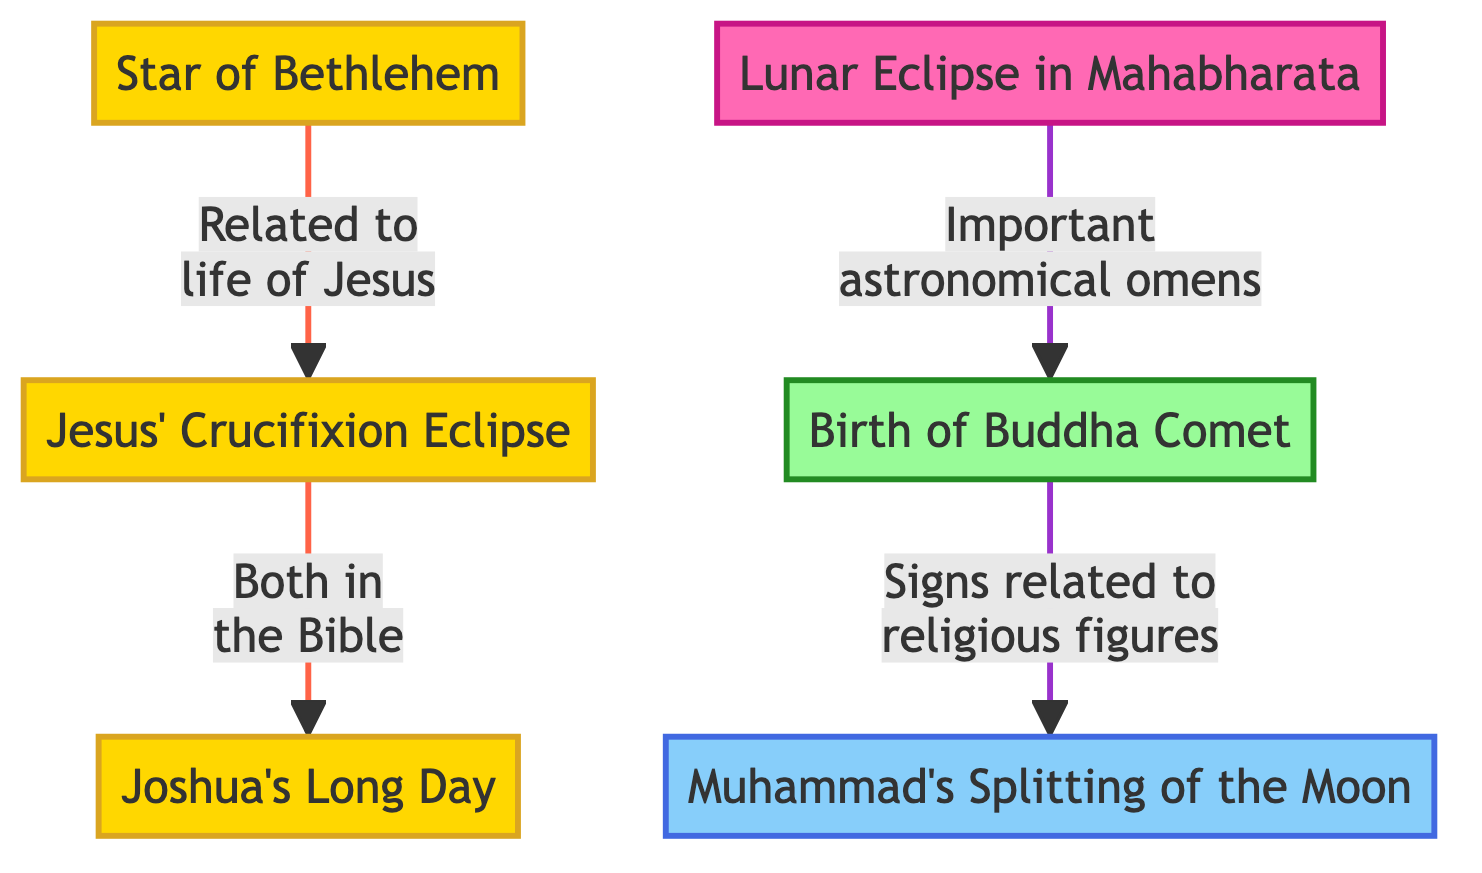What is the first event listed in the diagram? The first node in the diagram is "Star of Bethlehem," which can be identified as it is the topmost node and the starting point of the relationships shown.
Answer: Star of Bethlehem How many nodes are in the diagram? By counting all the nodes displayed in the diagram, we find a total of six events connected by relationships.
Answer: 6 Which two events are directly connected in the diagram? The nodes "Star of Bethlehem" and "Jesus' Crucifixion Eclipse" are directly linked, marked by an arrow that indicates a direct relationship between them.
Answer: Star of Bethlehem and Jesus' Crucifixion Eclipse What type of event is "Lunar Eclipse in Mahabharata"? The node "Lunar Eclipse in Mahabharata" is colored and categorized under Hindu events, signifying it relates to Hindu religious texts.
Answer: Hindu What event links "Birth of Buddha Comet" and "Muhammad's Splitting of the Moon"? The connection between "Birth of Buddha Comet" and "Muhammad's Splitting of the Moon" is expressed through the arrow showing they are linked by signs related to religious figures.
Answer: Birth of Buddha Comet Which two events in the diagram are related to the life of Jesus? The events that relate to the life of Jesus are "Star of Bethlehem" and "Jesus' Crucifixion Eclipse," as the connection explicitly states it relates to his life.
Answer: Star of Bethlehem and Jesus' Crucifixion Eclipse How are "Joshua's Long Day" and "Jesus' Crucifixion Eclipse" related? "Joshua's Long Day" is connected to "Jesus' Crucifixion Eclipse" through an arrow indicating they are both mentioned in biblical contexts, establishing a thematic link.
Answer: Both in the Bible What is the main theme connecting all the events illustrated? The predominant theme connecting all these events revolves around significant astronomical occurrences that have religious implications or symbolism in various religious texts.
Answer: Astronomical events Which religious tradition includes "Muhammad's Splitting of the Moon"? The node "Muhammad's Splitting of the Moon" is classified under the Islamic tradition, which can be deduced from its color coding and content.
Answer: Islamic 